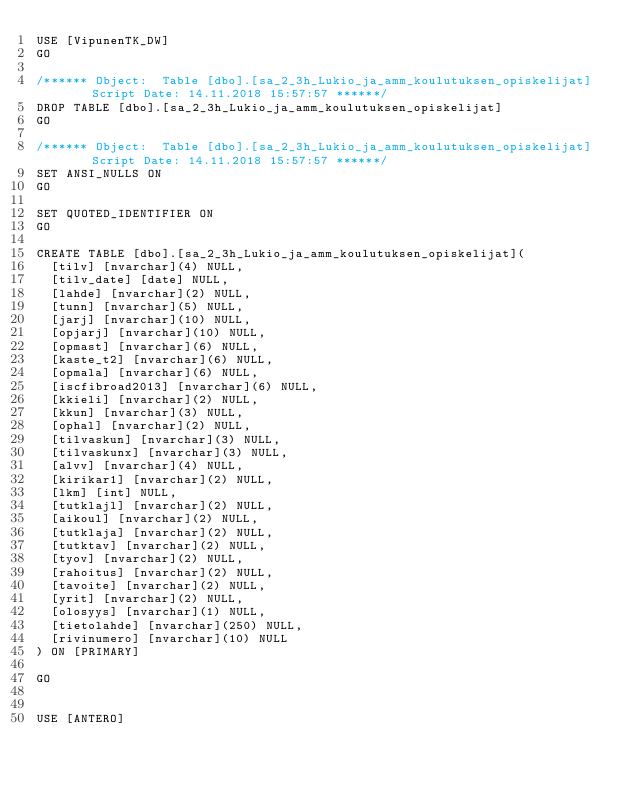Convert code to text. <code><loc_0><loc_0><loc_500><loc_500><_SQL_>USE [VipunenTK_DW]
GO

/****** Object:  Table [dbo].[sa_2_3h_Lukio_ja_amm_koulutuksen_opiskelijat]    Script Date: 14.11.2018 15:57:57 ******/
DROP TABLE [dbo].[sa_2_3h_Lukio_ja_amm_koulutuksen_opiskelijat]
GO

/****** Object:  Table [dbo].[sa_2_3h_Lukio_ja_amm_koulutuksen_opiskelijat]    Script Date: 14.11.2018 15:57:57 ******/
SET ANSI_NULLS ON
GO

SET QUOTED_IDENTIFIER ON
GO

CREATE TABLE [dbo].[sa_2_3h_Lukio_ja_amm_koulutuksen_opiskelijat](
	[tilv] [nvarchar](4) NULL,
	[tilv_date] [date] NULL,
	[lahde] [nvarchar](2) NULL,
	[tunn] [nvarchar](5) NULL,
	[jarj] [nvarchar](10) NULL,
	[opjarj] [nvarchar](10) NULL,
	[opmast] [nvarchar](6) NULL,
	[kaste_t2] [nvarchar](6) NULL,
	[opmala] [nvarchar](6) NULL,
	[iscfibroad2013] [nvarchar](6) NULL,
	[kkieli] [nvarchar](2) NULL,
	[kkun] [nvarchar](3) NULL,
	[ophal] [nvarchar](2) NULL,
	[tilvaskun] [nvarchar](3) NULL,
	[tilvaskunx] [nvarchar](3) NULL,
	[alvv] [nvarchar](4) NULL,
	[kirikar1] [nvarchar](2) NULL,
	[lkm] [int] NULL,
	[tutklajl] [nvarchar](2) NULL,
	[aikoul] [nvarchar](2) NULL,
	[tutklaja] [nvarchar](2) NULL,
	[tutktav] [nvarchar](2) NULL,
	[tyov] [nvarchar](2) NULL,
	[rahoitus] [nvarchar](2) NULL,
	[tavoite] [nvarchar](2) NULL,
	[yrit] [nvarchar](2) NULL,
	[olosyys] [nvarchar](1) NULL,
	[tietolahde] [nvarchar](250) NULL,
	[rivinumero] [nvarchar](10) NULL
) ON [PRIMARY]

GO


USE [ANTERO]</code> 